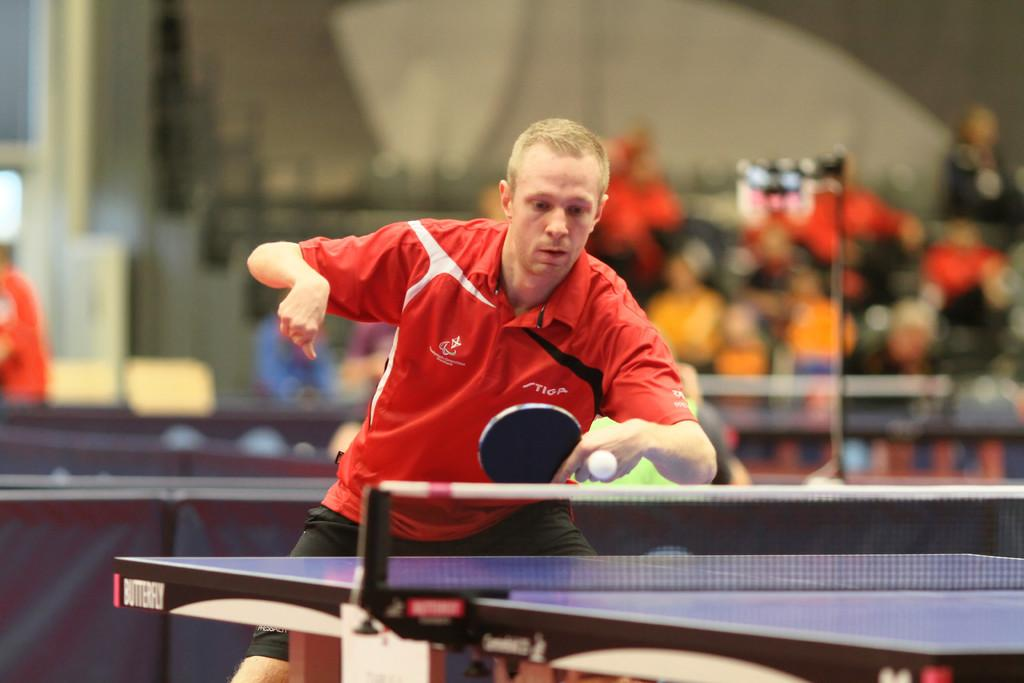What can be observed about the background of the image? The background of the image is blurry. Can you describe the people in the image? There are persons in the image, including a man. What is the man wearing in the image? The man is wearing a red t-shirt. What activity is the man engaged in? The man is playing table tennis. What piece of equipment is used for the activity in the image? There is a table tennis table in the image. What type of food is being served at the attraction in the image? There is no attraction or food present in the image; it features a man playing table tennis. What action is the man taking with the food in the image? There is no food or action related to food in the image; the man is playing table tennis. 